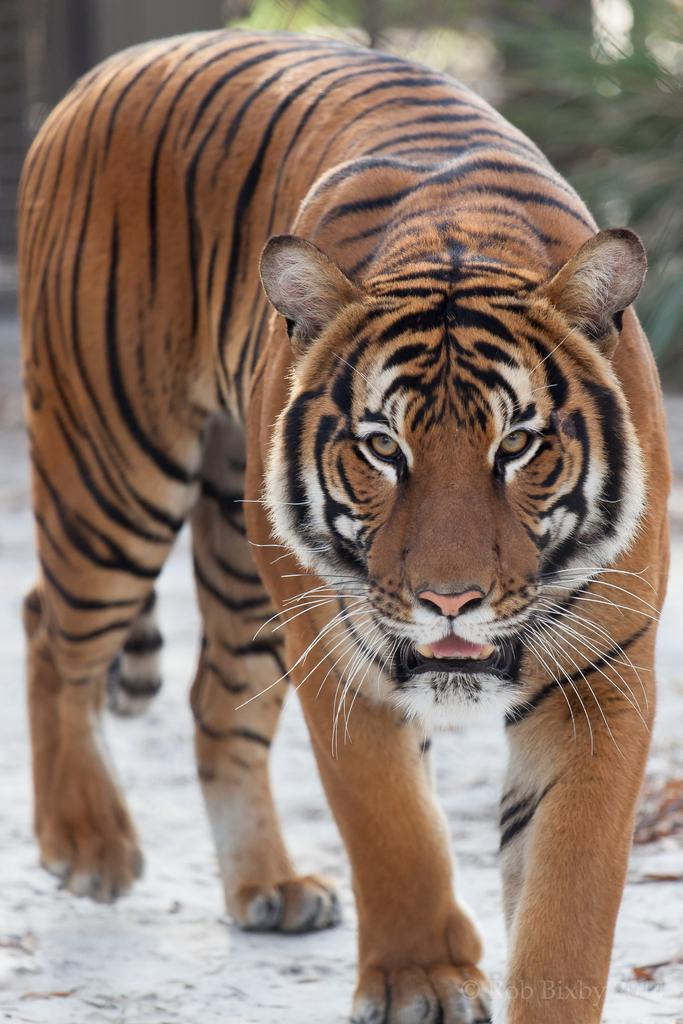What animal is in the image? There is a tiger in the image. What is the tiger doing in the image? The tiger is walking on the ground. Can you describe the background of the image? The background of the image is blurry. What type of lipstick is the tiger wearing in the image? There is no lipstick or any indication of cosmetics in the image, as it features a tiger walking on the ground with a blurry background. 